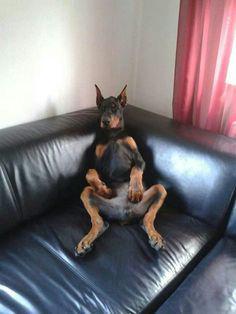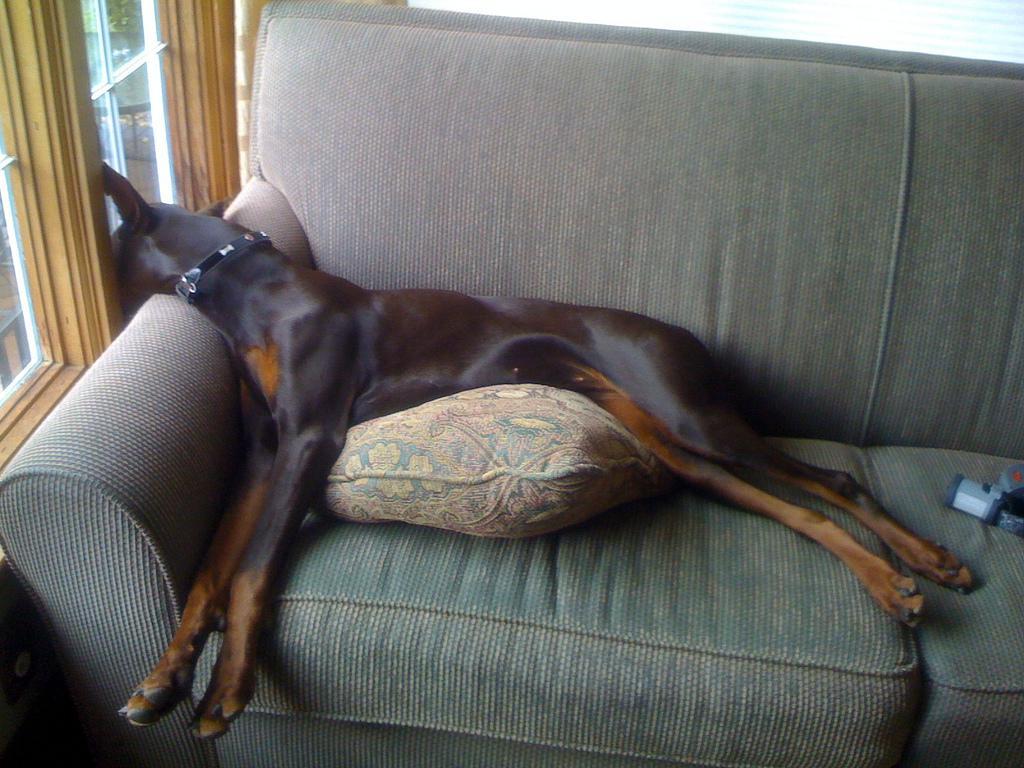The first image is the image on the left, the second image is the image on the right. Assess this claim about the two images: "All dogs shown are sleeping on their backs with their front paws bent, and the dog on the right has its head flung back and its muzzle at the lower right.". Correct or not? Answer yes or no. No. The first image is the image on the left, the second image is the image on the right. Examine the images to the left and right. Is the description "Both images show a dog sleeping on their back exposing their belly." accurate? Answer yes or no. No. 